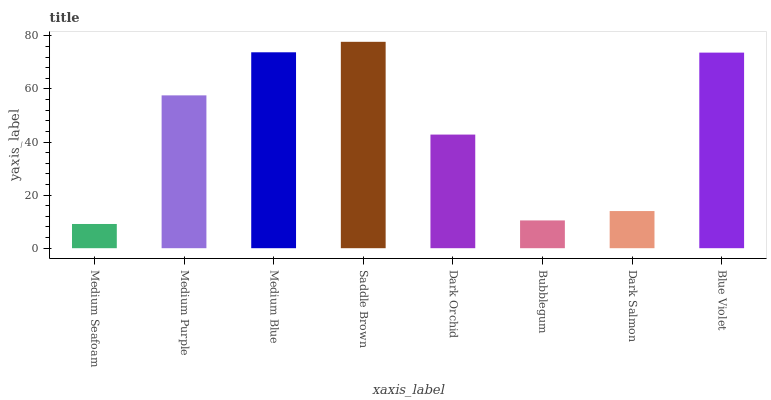Is Medium Seafoam the minimum?
Answer yes or no. Yes. Is Saddle Brown the maximum?
Answer yes or no. Yes. Is Medium Purple the minimum?
Answer yes or no. No. Is Medium Purple the maximum?
Answer yes or no. No. Is Medium Purple greater than Medium Seafoam?
Answer yes or no. Yes. Is Medium Seafoam less than Medium Purple?
Answer yes or no. Yes. Is Medium Seafoam greater than Medium Purple?
Answer yes or no. No. Is Medium Purple less than Medium Seafoam?
Answer yes or no. No. Is Medium Purple the high median?
Answer yes or no. Yes. Is Dark Orchid the low median?
Answer yes or no. Yes. Is Blue Violet the high median?
Answer yes or no. No. Is Medium Seafoam the low median?
Answer yes or no. No. 